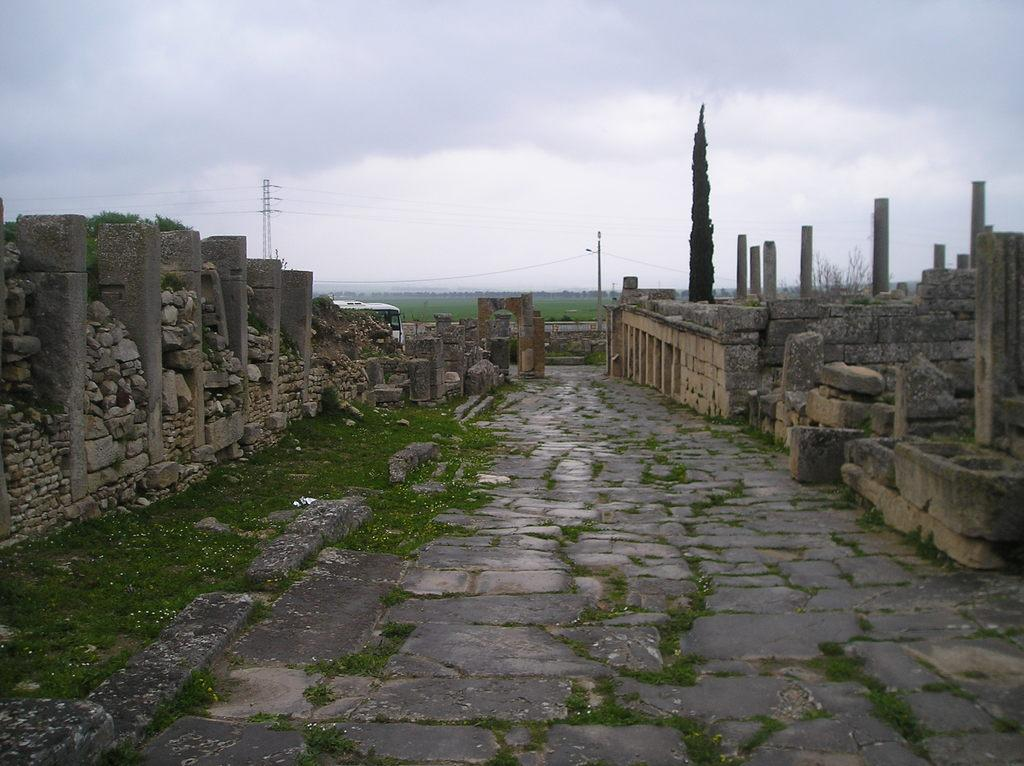What type of structure can be seen in the image? There is an architectural structure in the image. What material is visible in the image? There are stones visible in the image. What type of vegetation is present in the image? There are trees in the image. What is on the ground in the image? There is grass on the ground in the image. What is visible at the top of the image? The sky is visible at the top of the image. Where is the lamp located in the image? There is no lamp present in the image. What type of structure is depicted in the image? The provided facts do not specify the type of architectural structure; it could be a house, a castle, a temple, or any other type of building. 